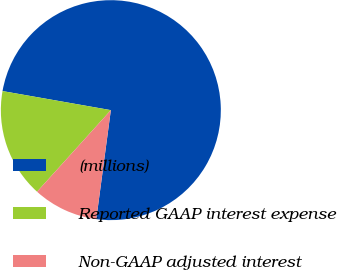Convert chart. <chart><loc_0><loc_0><loc_500><loc_500><pie_chart><fcel>(millions)<fcel>Reported GAAP interest expense<fcel>Non-GAAP adjusted interest<nl><fcel>74.34%<fcel>16.07%<fcel>9.59%<nl></chart> 